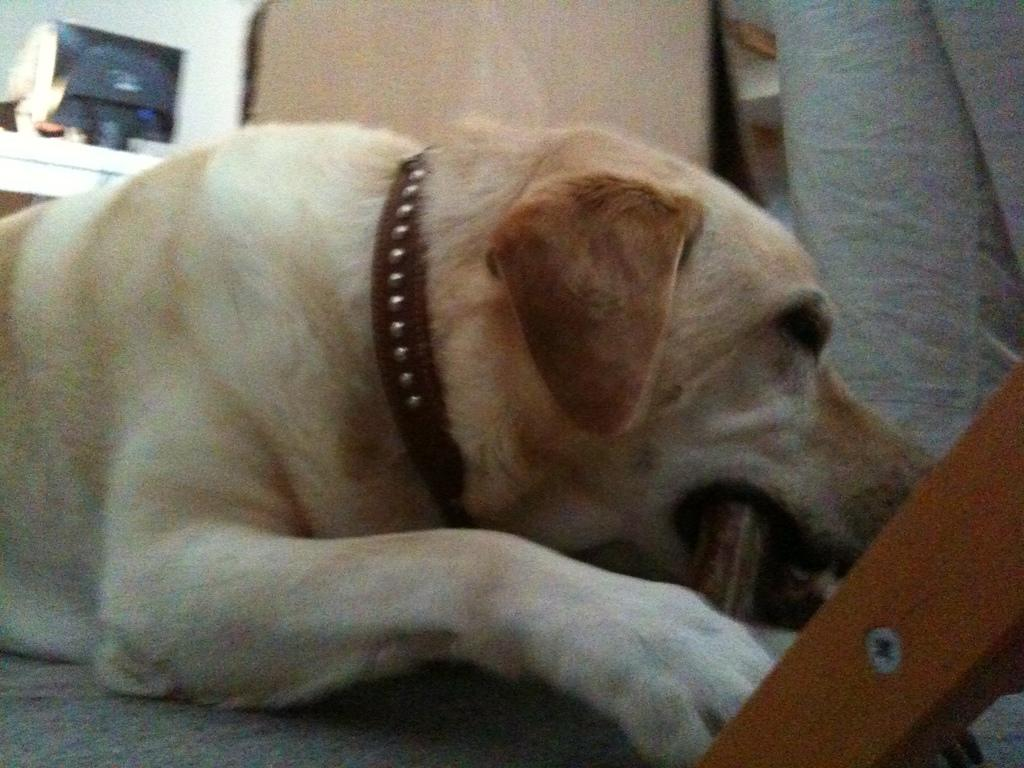What type of animal is in the image? There is a cream-colored dog in the image. Can you describe any distinguishing features of the dog? The dog has a brown-colored belt around its neck. What else can be seen in the image, besides the dog? There are unspecified "stuffs" visible in the top left corner of the image. Can you hear the dog's theory about the stuffs in the top left corner of the image? There is no indication in the image that the dog has a theory or that it can communicate its thoughts through sound. 